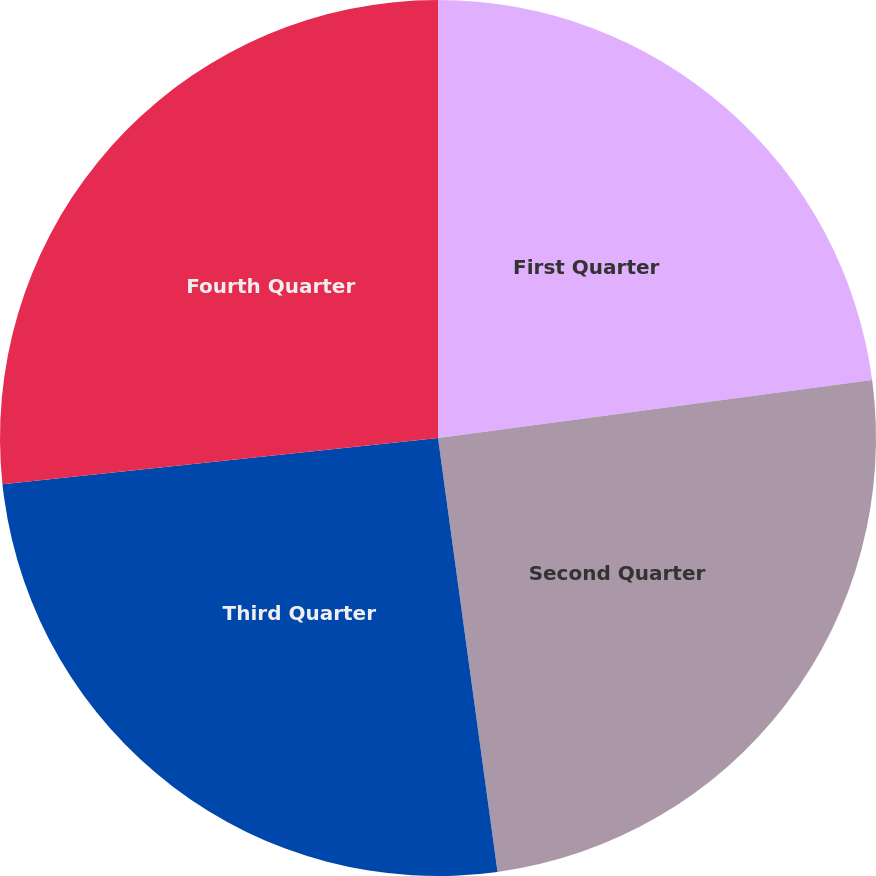<chart> <loc_0><loc_0><loc_500><loc_500><pie_chart><fcel>First Quarter<fcel>Second Quarter<fcel>Third Quarter<fcel>Fourth Quarter<nl><fcel>22.89%<fcel>24.94%<fcel>25.49%<fcel>26.68%<nl></chart> 